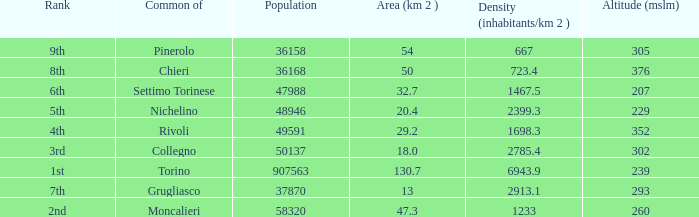The common of Chieri has what population density? 723.4. 